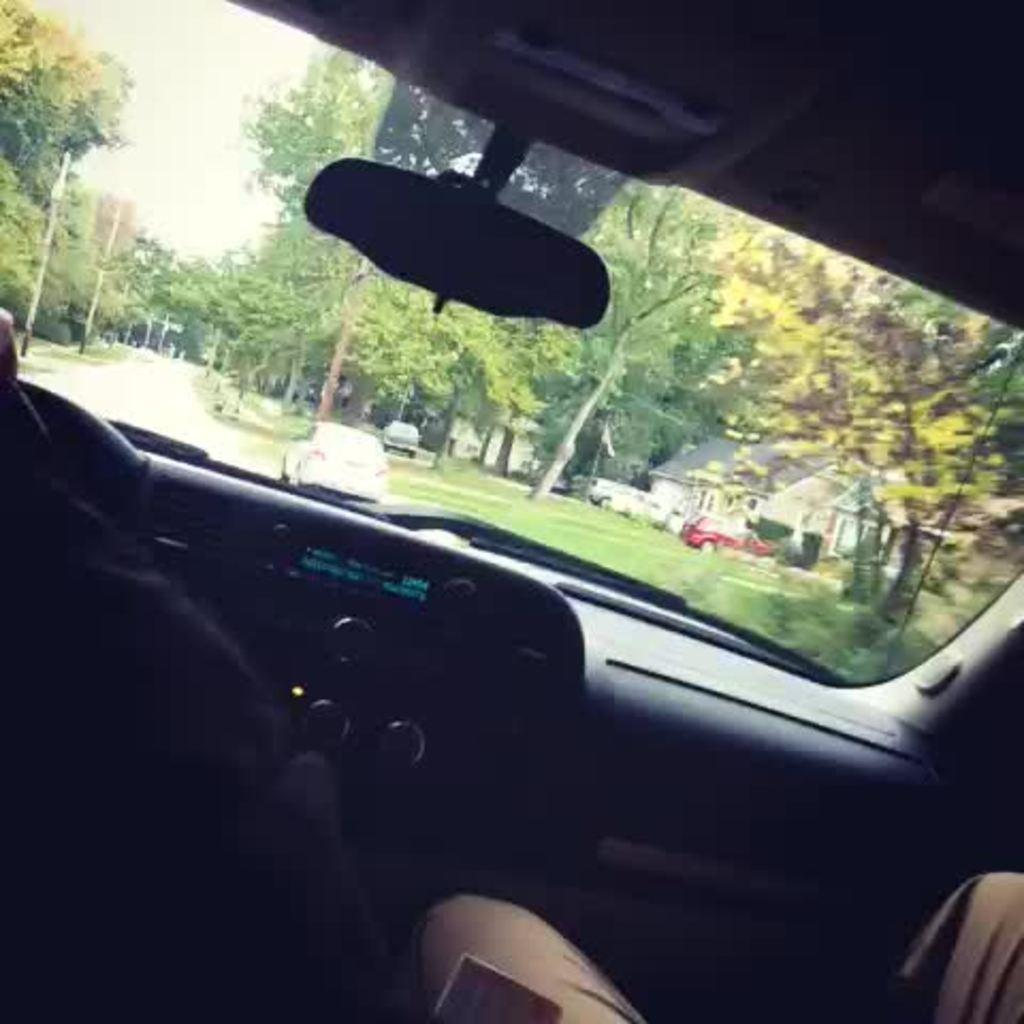What is the setting of the image? The image shows the inside view of a car. Who or what can be seen inside the car? There are people inside the car. What part of the car is visible in the image? The car's dashboard and windshield are visible. What can be seen outside the car through the windshield? Trees, a house, and other vehicles are visible outside the car. What type of milk is being consumed by the people inside the car? There is no milk visible or mentioned in the image. What account number is written on the car's dashboard? There is no account number visible or mentioned on the car's dashboard in the image. 